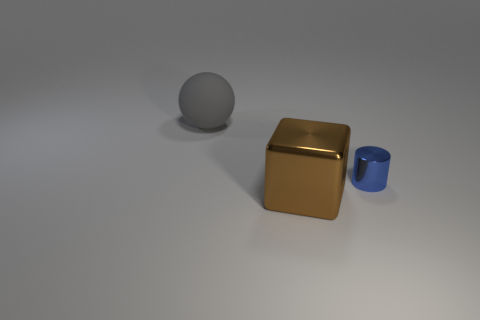Add 3 big red things. How many objects exist? 6 Subtract all cylinders. How many objects are left? 2 Subtract 0 yellow balls. How many objects are left? 3 Subtract all purple balls. Subtract all purple blocks. How many balls are left? 1 Subtract all green cylinders. Subtract all metallic blocks. How many objects are left? 2 Add 1 rubber spheres. How many rubber spheres are left? 2 Add 3 large rubber cubes. How many large rubber cubes exist? 3 